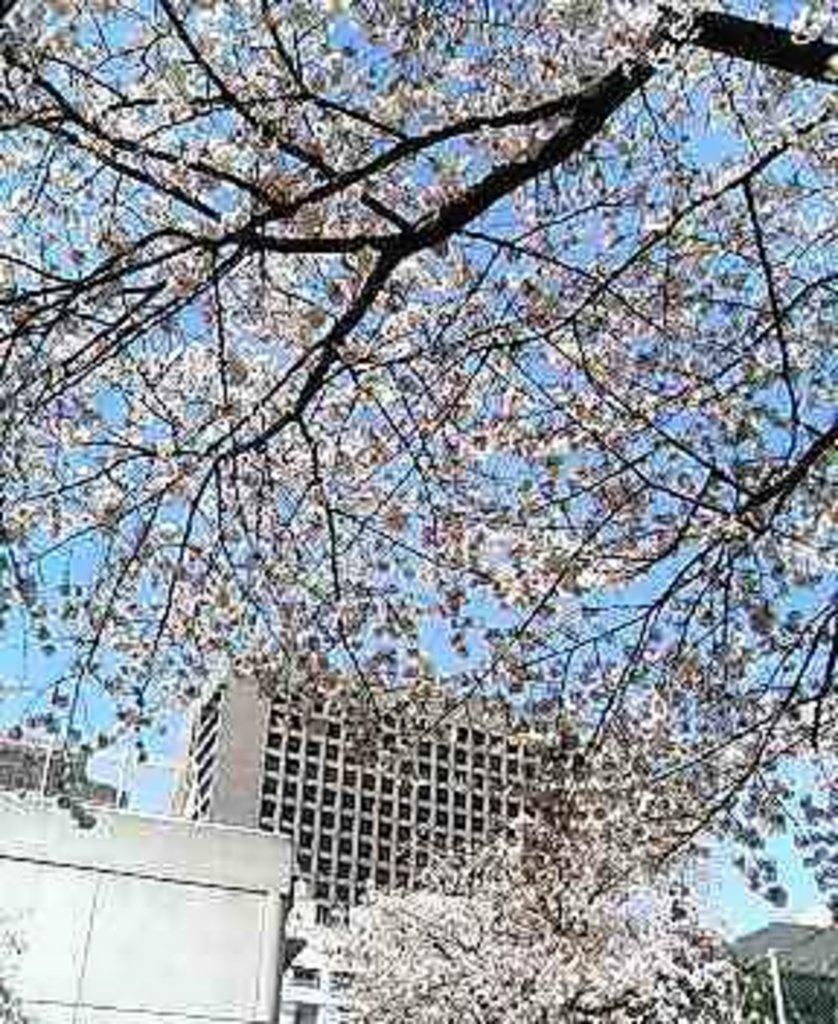What type of vegetation is in the foreground of the image? There are trees in the foreground of the image. What type of structures can be seen in the background of the image? There are buildings in the background of the image. What part of the natural environment is visible in the background of the image? The sky is visible in the background of the image. Is there any gold visible in the image? There is no mention of gold in the provided facts, so it cannot be determined if gold is present in the image. Can you confirm the existence of a farmer in the image? There is no mention of a farmer in the provided facts, so it cannot be determined if a farmer is present in the image. 